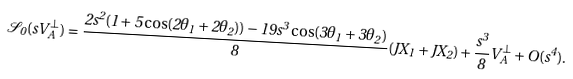<formula> <loc_0><loc_0><loc_500><loc_500>\mathcal { S } _ { 0 } ( s V _ { A } ^ { \perp } ) = \frac { 2 s ^ { 2 } ( 1 + 5 \cos ( 2 \theta _ { 1 } + 2 \theta _ { 2 } ) ) - 1 9 s ^ { 3 } \cos ( 3 \theta _ { 1 } + 3 \theta _ { 2 } ) } { 8 } ( J X _ { 1 } + J X _ { 2 } ) + \frac { s ^ { 3 } } { 8 } V _ { A } ^ { \perp } + O ( s ^ { 4 } ) .</formula> 